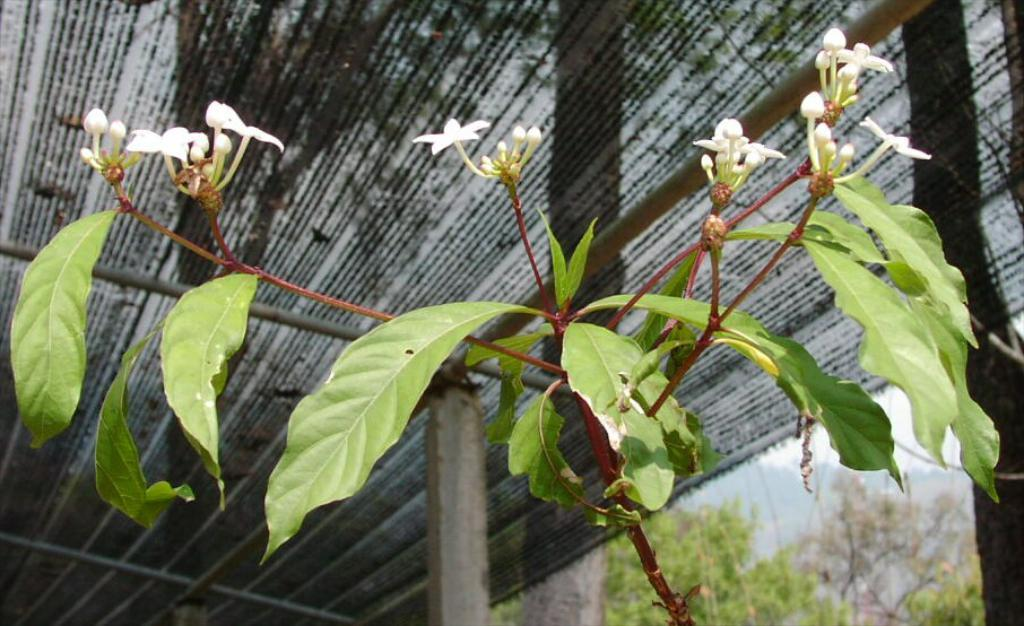What type of plant is in the image? There is a flower plant in the image. What structure is visible in the image? There is a roof in the image. What can be seen in the background of the image? There are trees in the background of the image. How many wrens can be seen perched on the roof in the image? There are no wrens present in the image. Is there a knife visible in the image? There is no knife present in the image. Can you see any sheep in the image? There are no sheep present in the image. 